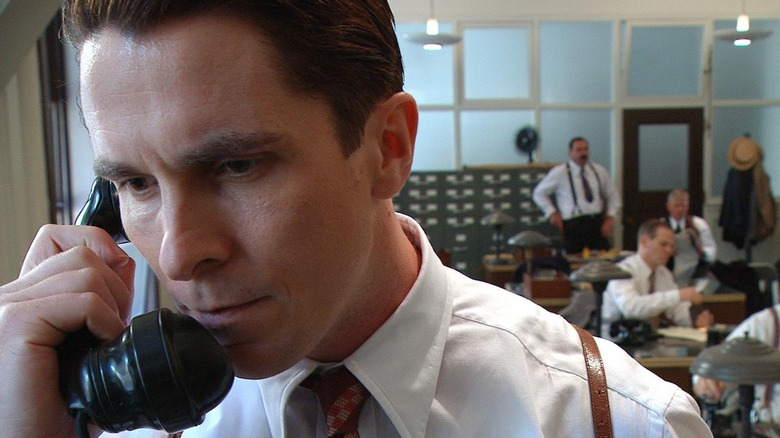What might the man sitting at the desk be thinking about? The man sitting at the desk is likely consumed by thoughts of the intricate details of their operations. He might be worrying about the financial aspects, ensuring that every penny is accounted for in the ledgers before him. His concentrated expression suggests he may be troubleshooting a discrepancy he found or planning out budgets for future shows. Alternatively, he could be reflecting on the performance's success, considering improvements, or strategizing for upcoming events to ensure continued success and profitability for the troupe. Can you imagine an extremely detailed backstory for the man standing by the hat rack? Certainly! The man standing by the hat rack is James Everett, a former stagehand who worked his way up to become the chief stage manager for the magic troupe. James grew up in a small town where he was fascinated by the traveling circuses that occasionally passed through. His dream was to be part of the magical world he admired so much. After years of dedication and learning the trade, he developed an acute eye for detail, ensuring that every prop and illusion was flawlessly executed. Known for his strict regimen and no-nonsense attitude, he commands respect from his colleagues but is also known to have a compassionate side, often mentoring younger staff. James had a brief stint on stage in his youth, which grants him unique insight into the needs and psyche of the performers he now manages. His presence near the hat rack signifies his readiness to assist and his hands-on approach to management. Perhaps he is reminiscing about his early days while ensuring today’s performance lives up to the legacy of the troupe. His wife, Emily, also works for the troupe as a costume designer, and they share a deep bond built over years of shared hard work and countless performances. Every item and action holds sentimental value and professional precision, encapsulating James’s ethos of dedication and love for the craft. What if the black telephone Alfred Borden is holding could transport him to any moment in time? If the black telephone Alfred Borden is holding could transport him to any moment in time, it would add a profound twist to the story. As he grips the receiver, he could choose to venture into pivotal moments of history or personal significance. For instance, Alfred might decide to visit the era of Nikola Tesla to uncover deeper secrets of electrical wonders and scientific breakthroughs that could revolutionize his magic tricks. Alternatively, he might transport himself back to a moment in his own life that he wishes to alter, perhaps a key event that changed the course of his career or personal relationships. This time-traveling telephone could also serve as a tool to witness legendary performances of past magicians, drawing inspiration and learning closely-guarded secrets. Each journey through time would come with its own set of challenges and revelations, embedding layers of complexity to his character’s development in 'The Prestige.' Such an element would undoubtedly enrich the narrative, merging the realms of magic and science fiction into a seamless blend of imaginative storytelling. Create a dialogue between Alfred Borden and the man standing near the hat rack, discussing the next big magic show. Alfred Borden (holding the phone): "James, do we have everything sorted for the next performance?"

James Everett (standing near the hat rack): "Yes, Alfred. Every prop has been triple-checked, and the new illusion setup is almost complete. We only need to finalize the timing cues for the assistants."

Alfred Borden: "Good. Timing is everything. We can't afford any mistakes, especially with the new act. Have the stagehands been briefed on the changes?"

James Everett: "Absolutely. I personally went through the plans with them this morning. They know their roles down to the second. But we still need to run a full rehearsal, just to be sure."

Alfred Borden: "Perfect. I'll trust your judgement, James. Make sure to remind everyone that the stakes are higher this time. Our reputation depends on the flawless execution of every trick."

James Everett: "Consider it done. We'll make sure the show is unlike anything the audience has ever seen before."

Alfred Borden: "Thanks, James. Let’s make this show the one they talk about for years to come." 